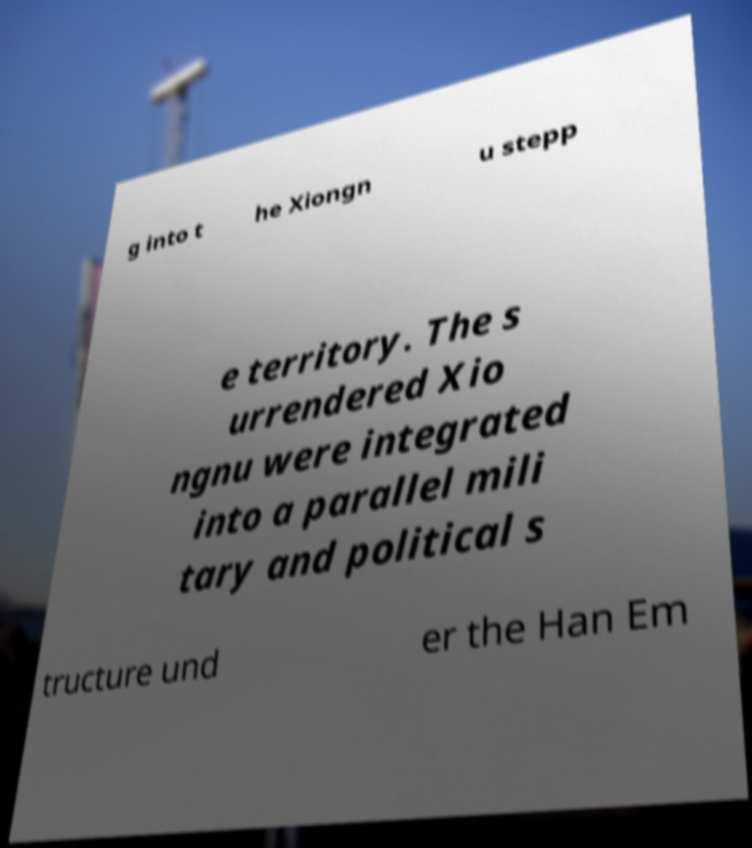Please read and relay the text visible in this image. What does it say? g into t he Xiongn u stepp e territory. The s urrendered Xio ngnu were integrated into a parallel mili tary and political s tructure und er the Han Em 